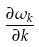<formula> <loc_0><loc_0><loc_500><loc_500>\frac { \partial \omega _ { k } } { \partial k }</formula> 